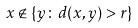Convert formula to latex. <formula><loc_0><loc_0><loc_500><loc_500>x \notin \{ y \colon d ( x , y ) > r \}</formula> 